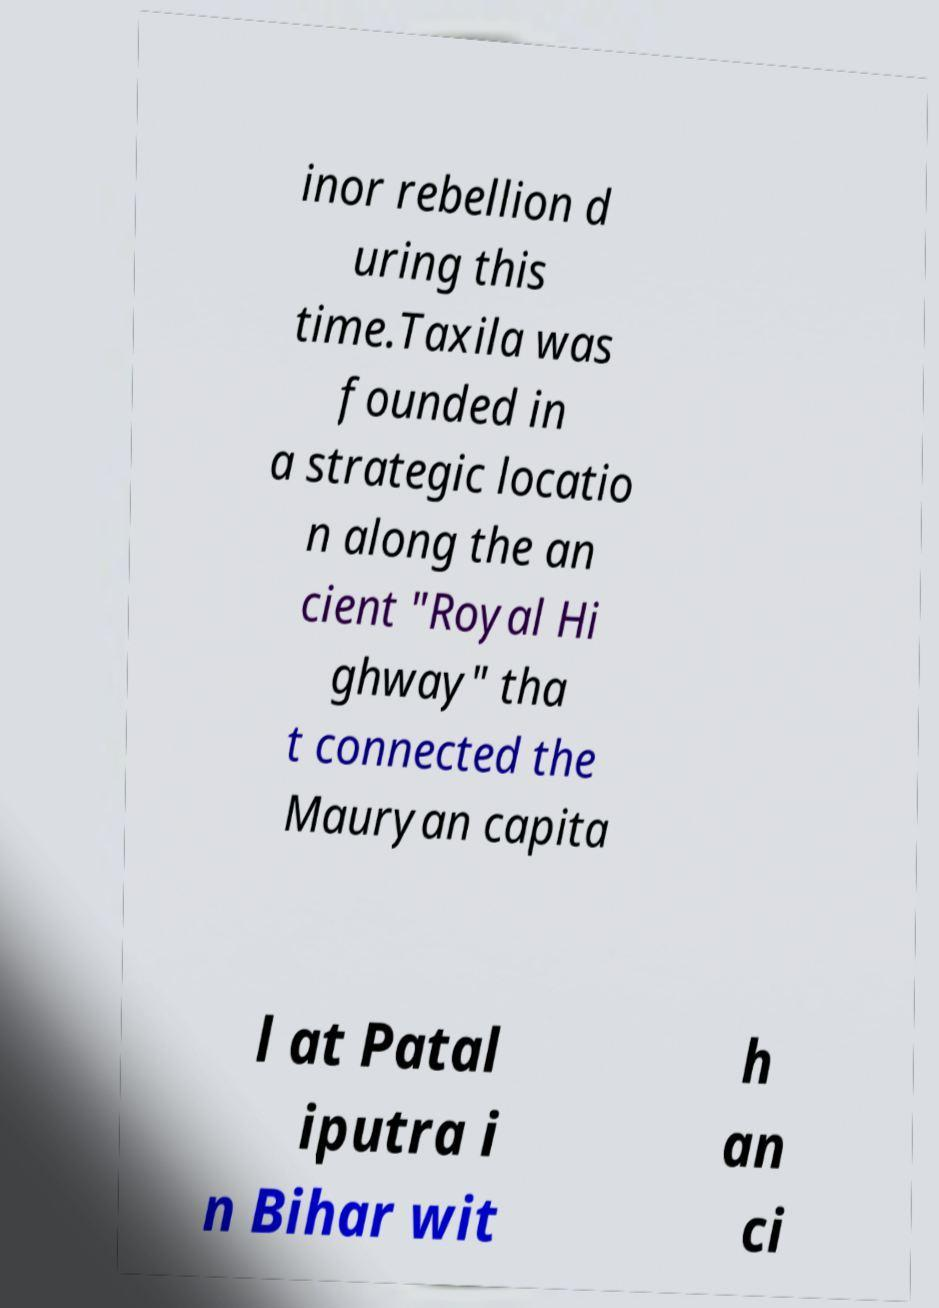Can you accurately transcribe the text from the provided image for me? inor rebellion d uring this time.Taxila was founded in a strategic locatio n along the an cient "Royal Hi ghway" tha t connected the Mauryan capita l at Patal iputra i n Bihar wit h an ci 